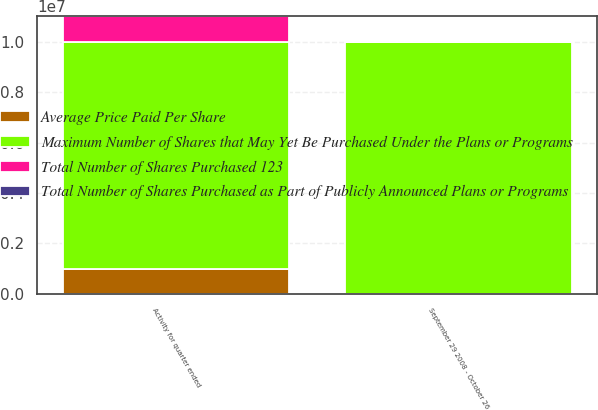Convert chart. <chart><loc_0><loc_0><loc_500><loc_500><stacked_bar_chart><ecel><fcel>September 29 2008 - October 26<fcel>Activity for quarter ended<nl><fcel>Total Number of Shares Purchased 123<fcel>16618<fcel>1.01662e+06<nl><fcel>Total Number of Shares Purchased as Part of Publicly Announced Plans or Programs<fcel>20.69<fcel>18.05<nl><fcel>Average Price Paid Per Share<fcel>0<fcel>1e+06<nl><fcel>Maximum Number of Shares that May Yet Be Purchased Under the Plans or Programs<fcel>1e+07<fcel>9e+06<nl></chart> 